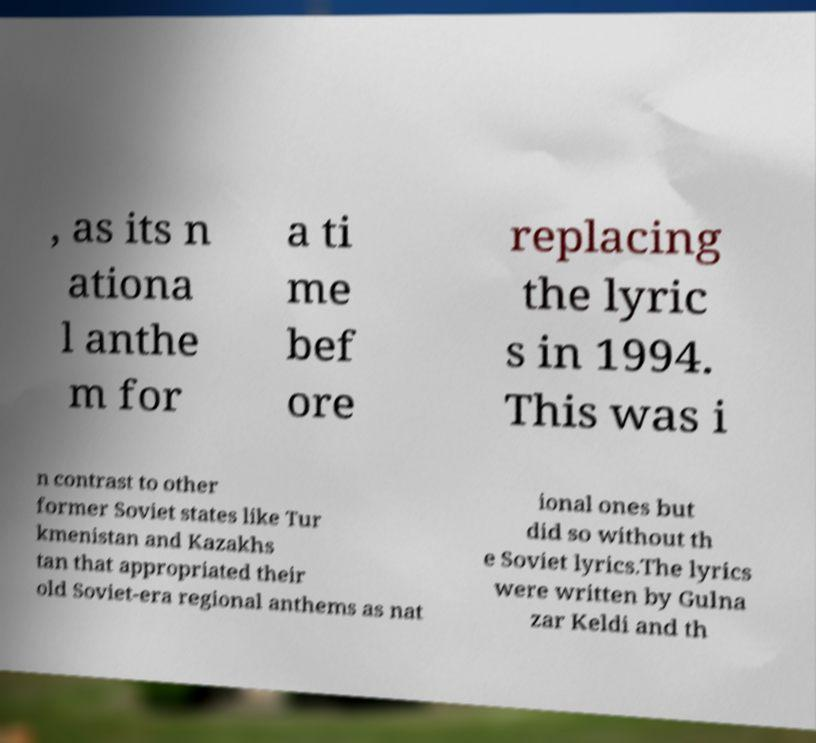Can you read and provide the text displayed in the image?This photo seems to have some interesting text. Can you extract and type it out for me? , as its n ationa l anthe m for a ti me bef ore replacing the lyric s in 1994. This was i n contrast to other former Soviet states like Tur kmenistan and Kazakhs tan that appropriated their old Soviet-era regional anthems as nat ional ones but did so without th e Soviet lyrics.The lyrics were written by Gulna zar Keldi and th 